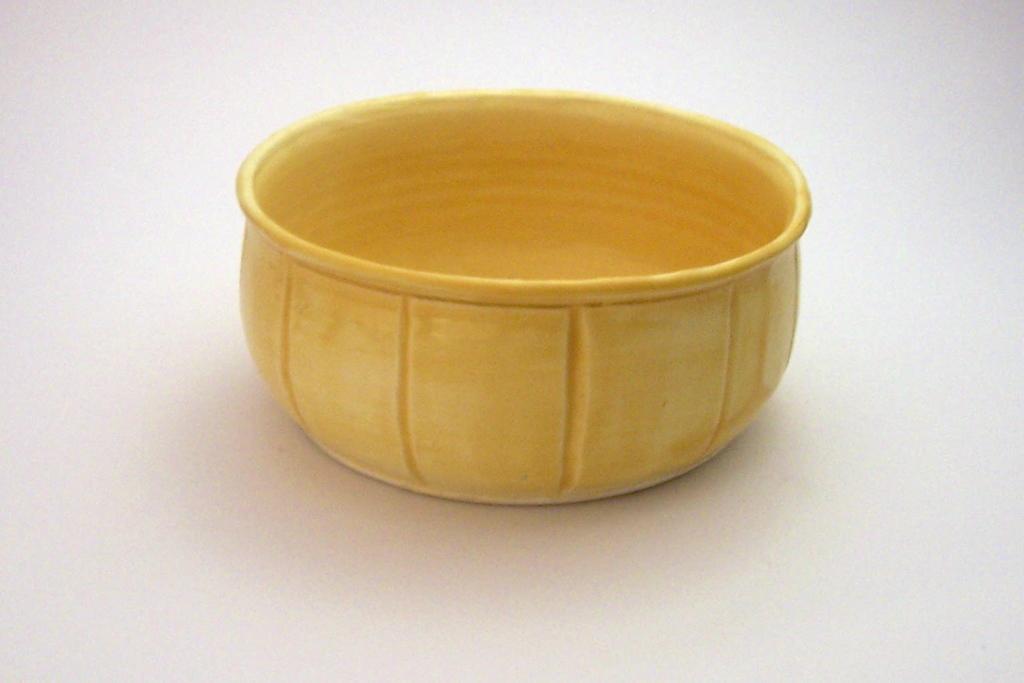How would you summarize this image in a sentence or two? In the center of the picture there is a bowl on a white surface. 